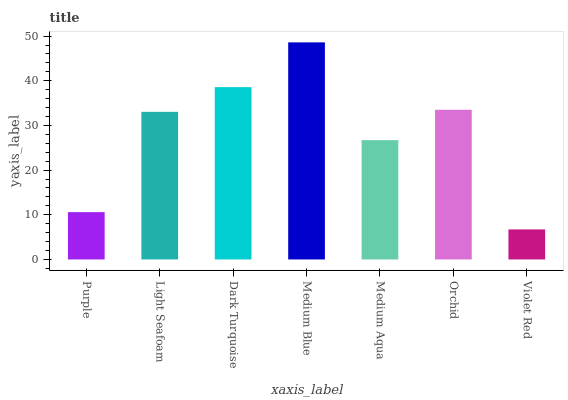Is Violet Red the minimum?
Answer yes or no. Yes. Is Medium Blue the maximum?
Answer yes or no. Yes. Is Light Seafoam the minimum?
Answer yes or no. No. Is Light Seafoam the maximum?
Answer yes or no. No. Is Light Seafoam greater than Purple?
Answer yes or no. Yes. Is Purple less than Light Seafoam?
Answer yes or no. Yes. Is Purple greater than Light Seafoam?
Answer yes or no. No. Is Light Seafoam less than Purple?
Answer yes or no. No. Is Light Seafoam the high median?
Answer yes or no. Yes. Is Light Seafoam the low median?
Answer yes or no. Yes. Is Violet Red the high median?
Answer yes or no. No. Is Purple the low median?
Answer yes or no. No. 